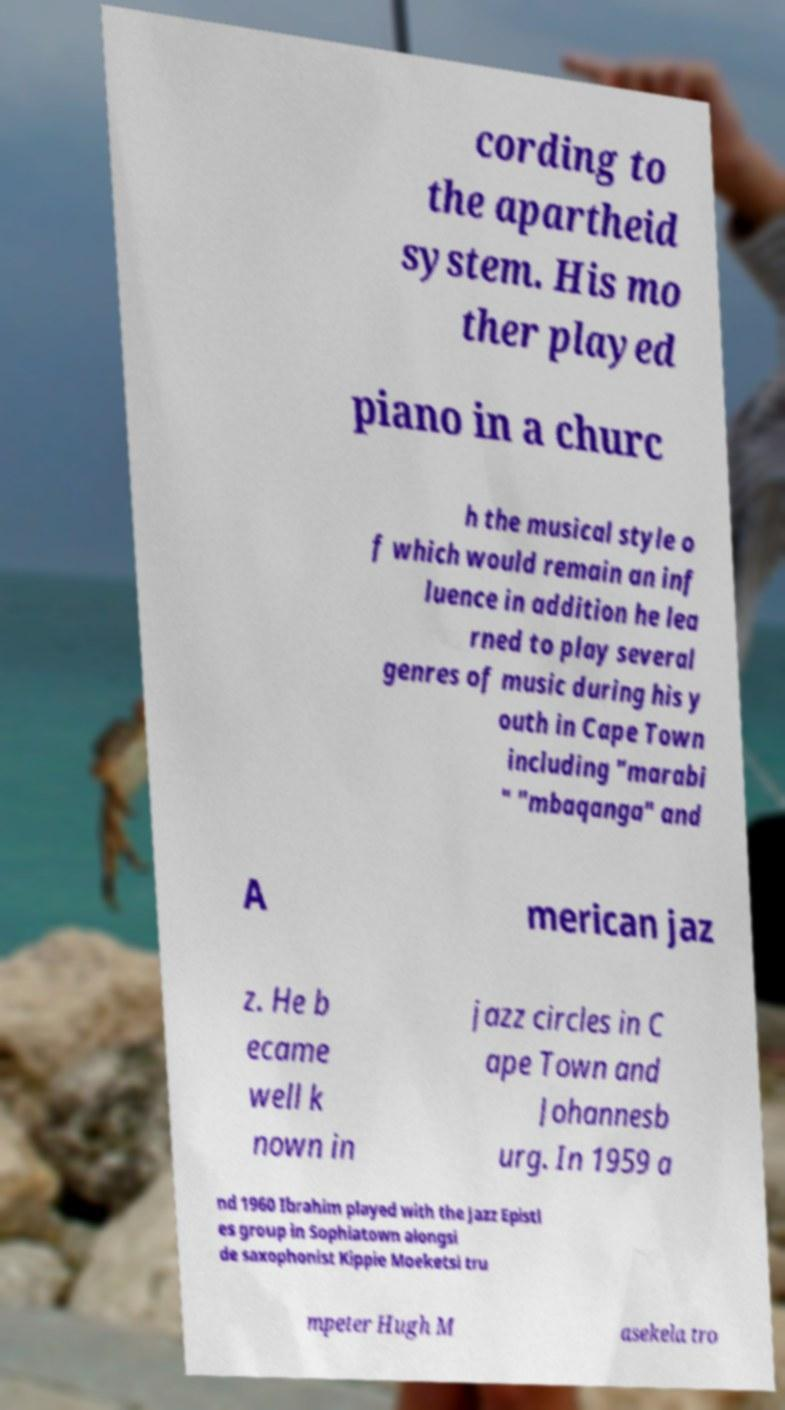Can you accurately transcribe the text from the provided image for me? cording to the apartheid system. His mo ther played piano in a churc h the musical style o f which would remain an inf luence in addition he lea rned to play several genres of music during his y outh in Cape Town including "marabi " "mbaqanga" and A merican jaz z. He b ecame well k nown in jazz circles in C ape Town and Johannesb urg. In 1959 a nd 1960 Ibrahim played with the Jazz Epistl es group in Sophiatown alongsi de saxophonist Kippie Moeketsi tru mpeter Hugh M asekela tro 